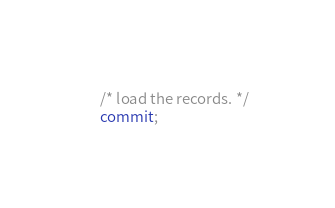Convert code to text. <code><loc_0><loc_0><loc_500><loc_500><_SQL_>/* load the records. */
commit;</code> 